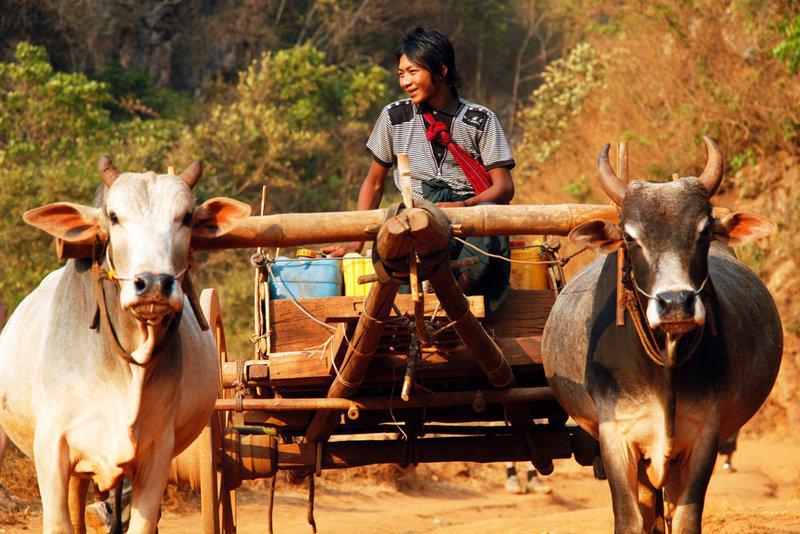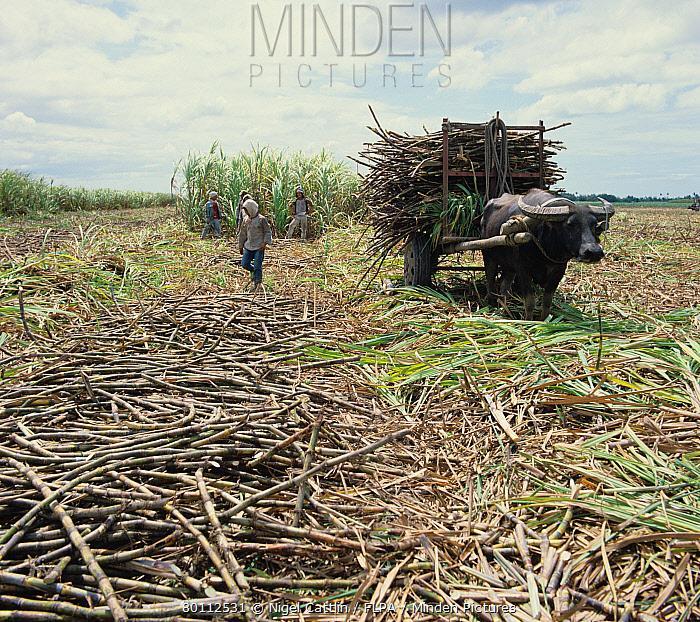The first image is the image on the left, the second image is the image on the right. Examine the images to the left and right. Is the description "In the left image, two oxen are yolked to the cart." accurate? Answer yes or no. Yes. The first image is the image on the left, the second image is the image on the right. Analyze the images presented: Is the assertion "One image shows an ox pulling a cart with a thatched roof over passengers, and the other image shows at least one dark ox pulling a cart without a roof." valid? Answer yes or no. No. 